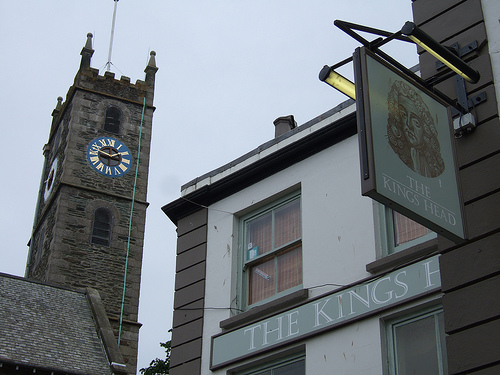Which side is the man on? The man is standing on the right side of the picture, positioned next to the pillar of the ground floor window. 